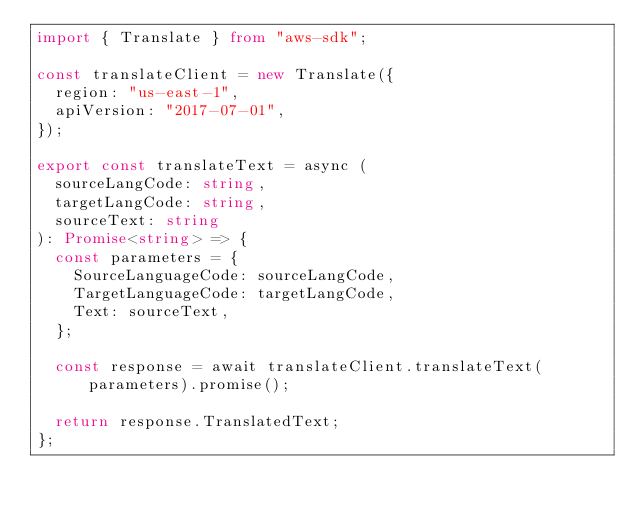<code> <loc_0><loc_0><loc_500><loc_500><_TypeScript_>import { Translate } from "aws-sdk";

const translateClient = new Translate({
	region: "us-east-1",
	apiVersion: "2017-07-01",
});

export const translateText = async (
	sourceLangCode: string,
	targetLangCode: string,
	sourceText: string
): Promise<string> => {
	const parameters = {
		SourceLanguageCode: sourceLangCode,
		TargetLanguageCode: targetLangCode,
		Text: sourceText,
	};

	const response = await translateClient.translateText(parameters).promise();

	return response.TranslatedText;
};
</code> 